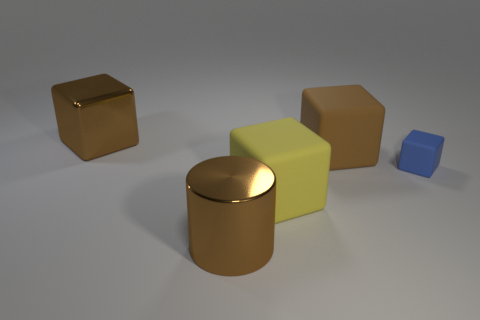Can you describe the texture differences among the objects? Certainly. There are two types of textures visible: shiny and matte. The cylinder and the cube on the left exhibit shiny surfaces, reflecting the light and surroundings, while the other objects have matte finishes that absorb light, resulting in a flat and non-reflective appearance. 